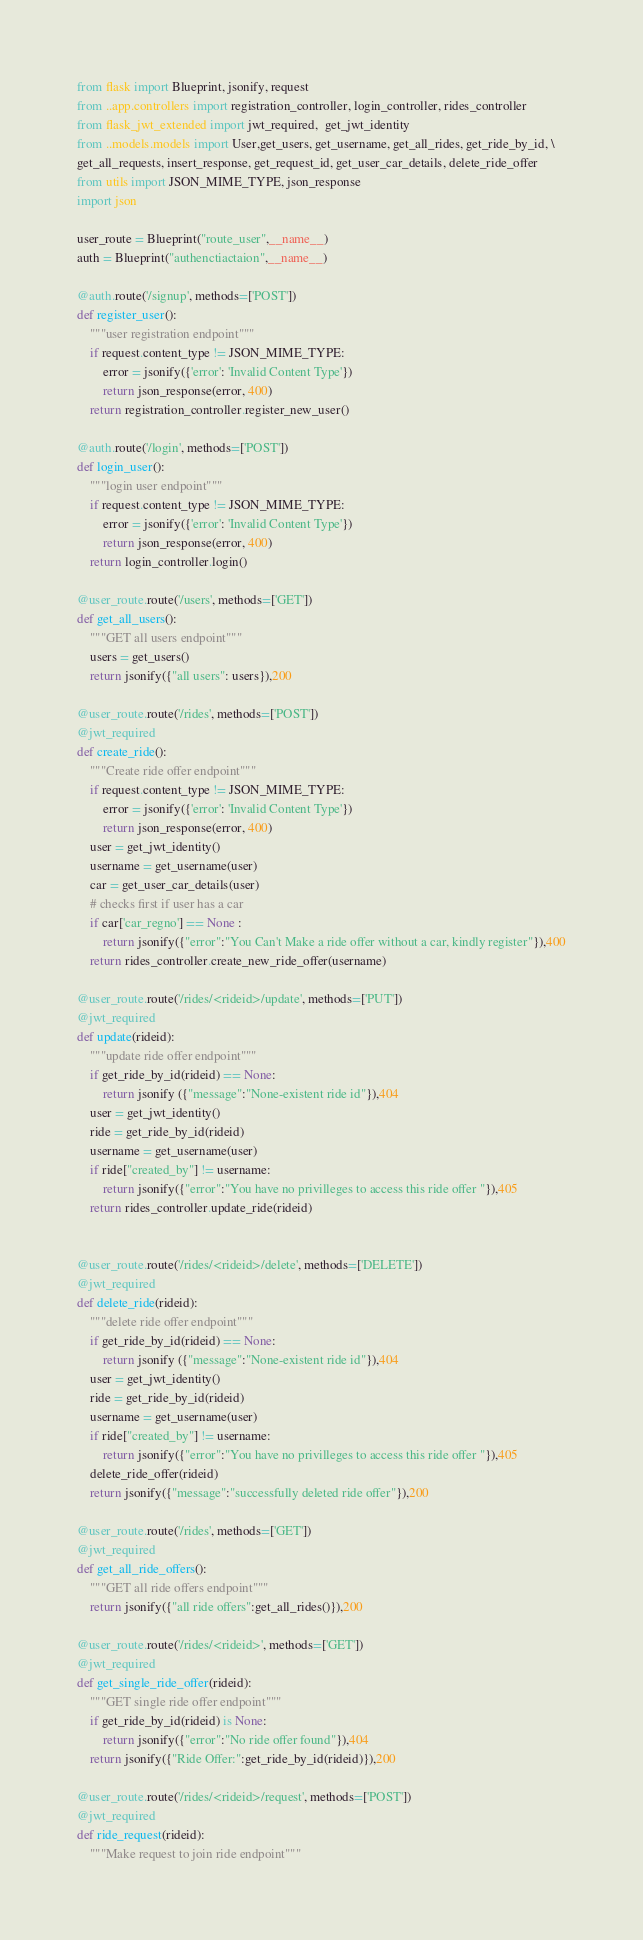<code> <loc_0><loc_0><loc_500><loc_500><_Python_>from flask import Blueprint, jsonify, request
from ..app.controllers import registration_controller, login_controller, rides_controller
from flask_jwt_extended import jwt_required,  get_jwt_identity  
from ..models.models import User,get_users, get_username, get_all_rides, get_ride_by_id, \
get_all_requests, insert_response, get_request_id, get_user_car_details, delete_ride_offer
from utils import JSON_MIME_TYPE, json_response
import json

user_route = Blueprint("route_user",__name__)
auth = Blueprint("authenctiactaion",__name__)

@auth.route('/signup', methods=['POST'])
def register_user():
    """user registration endpoint"""
    if request.content_type != JSON_MIME_TYPE:
        error = jsonify({'error': 'Invalid Content Type'})
        return json_response(error, 400)
    return registration_controller.register_new_user()

@auth.route('/login', methods=['POST'])
def login_user():
    """login user endpoint"""
    if request.content_type != JSON_MIME_TYPE:
        error = jsonify({'error': 'Invalid Content Type'})
        return json_response(error, 400)
    return login_controller.login()

@user_route.route('/users', methods=['GET'])
def get_all_users():
    """GET all users endpoint"""
    users = get_users()
    return jsonify({"all users": users}),200
   
@user_route.route('/rides', methods=['POST'])
@jwt_required
def create_ride():
    """Create ride offer endpoint"""  
    if request.content_type != JSON_MIME_TYPE:
        error = jsonify({'error': 'Invalid Content Type'})
        return json_response(error, 400)
    user = get_jwt_identity() 
    username = get_username(user)
    car = get_user_car_details(user)
    # checks first if user has a car
    if car['car_regno'] == None :
        return jsonify({"error":"You Can't Make a ride offer without a car, kindly register"}),400
    return rides_controller.create_new_ride_offer(username)

@user_route.route('/rides/<rideid>/update', methods=['PUT'])
@jwt_required
def update(rideid):
    """update ride offer endpoint"""
    if get_ride_by_id(rideid) == None:
        return jsonify ({"message":"None-existent ride id"}),404
    user = get_jwt_identity()
    ride = get_ride_by_id(rideid)
    username = get_username(user)
    if ride["created_by"] != username:
        return jsonify({"error":"You have no privilleges to access this ride offer "}),405
    return rides_controller.update_ride(rideid)


@user_route.route('/rides/<rideid>/delete', methods=['DELETE'])
@jwt_required
def delete_ride(rideid):
    """delete ride offer endpoint"""
    if get_ride_by_id(rideid) == None:
        return jsonify ({"message":"None-existent ride id"}),404
    user = get_jwt_identity()
    ride = get_ride_by_id(rideid)
    username = get_username(user)
    if ride["created_by"] != username:
        return jsonify({"error":"You have no privilleges to access this ride offer "}),405
    delete_ride_offer(rideid)
    return jsonify({"message":"successfully deleted ride offer"}),200

@user_route.route('/rides', methods=['GET'])
@jwt_required
def get_all_ride_offers():
    """GET all ride offers endpoint"""
    return jsonify({"all ride offers":get_all_rides()}),200

@user_route.route('/rides/<rideid>', methods=['GET'])
@jwt_required
def get_single_ride_offer(rideid):
    """GET single ride offer endpoint"""
    if get_ride_by_id(rideid) is None:
        return jsonify({"error":"No ride offer found"}),404
    return jsonify({"Ride Offer:":get_ride_by_id(rideid)}),200

@user_route.route('/rides/<rideid>/request', methods=['POST'])
@jwt_required
def ride_request(rideid):
    """Make request to join ride endpoint"""</code> 